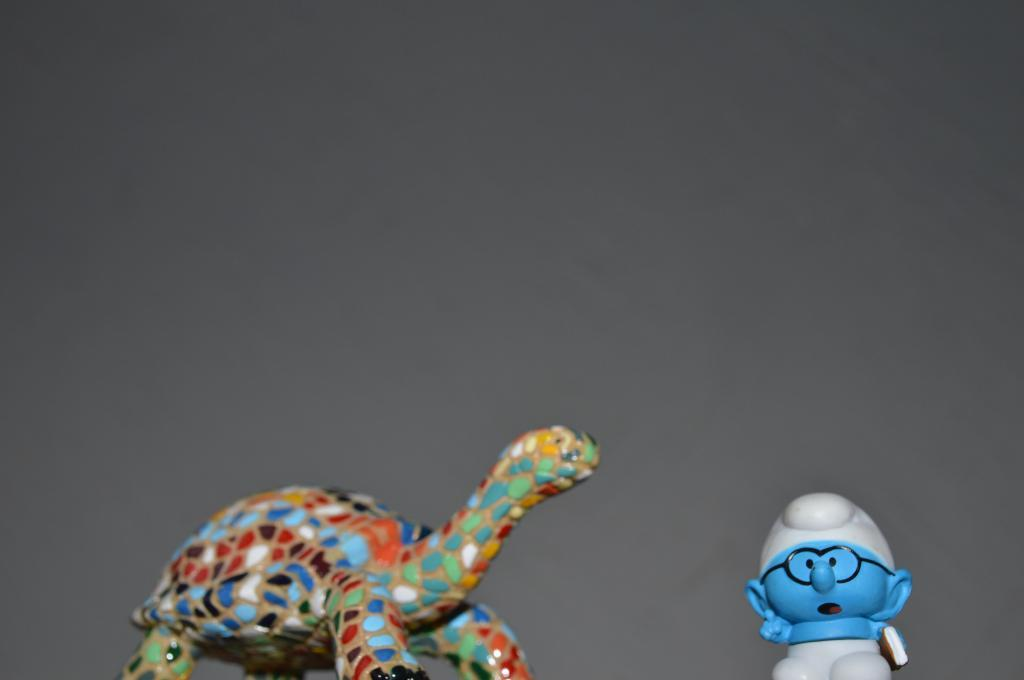What objects can be seen in the image? There are toys in the image. What color is the background of the image? The background of the image is white. Where can the honey be found in the image? There is no honey present in the image. What type of exercise can be performed at the station in the image? There is no station or exercise equipment present in the image. 